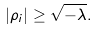Convert formula to latex. <formula><loc_0><loc_0><loc_500><loc_500>| \rho _ { i } | \geq \sqrt { - \lambda } .</formula> 